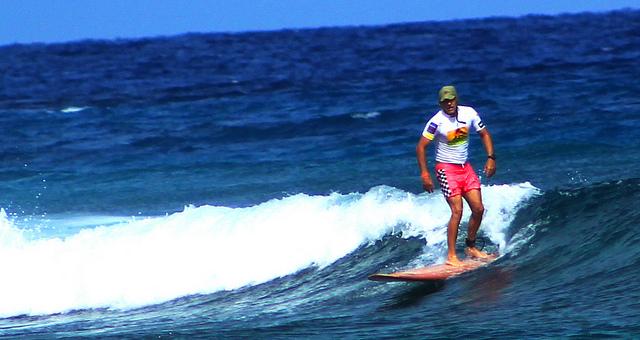Is he going for a swim?
Concise answer only. No. Is he wearing typical surfing apparel?
Write a very short answer. Yes. Are there any trees in the picture?
Quick response, please. No. 